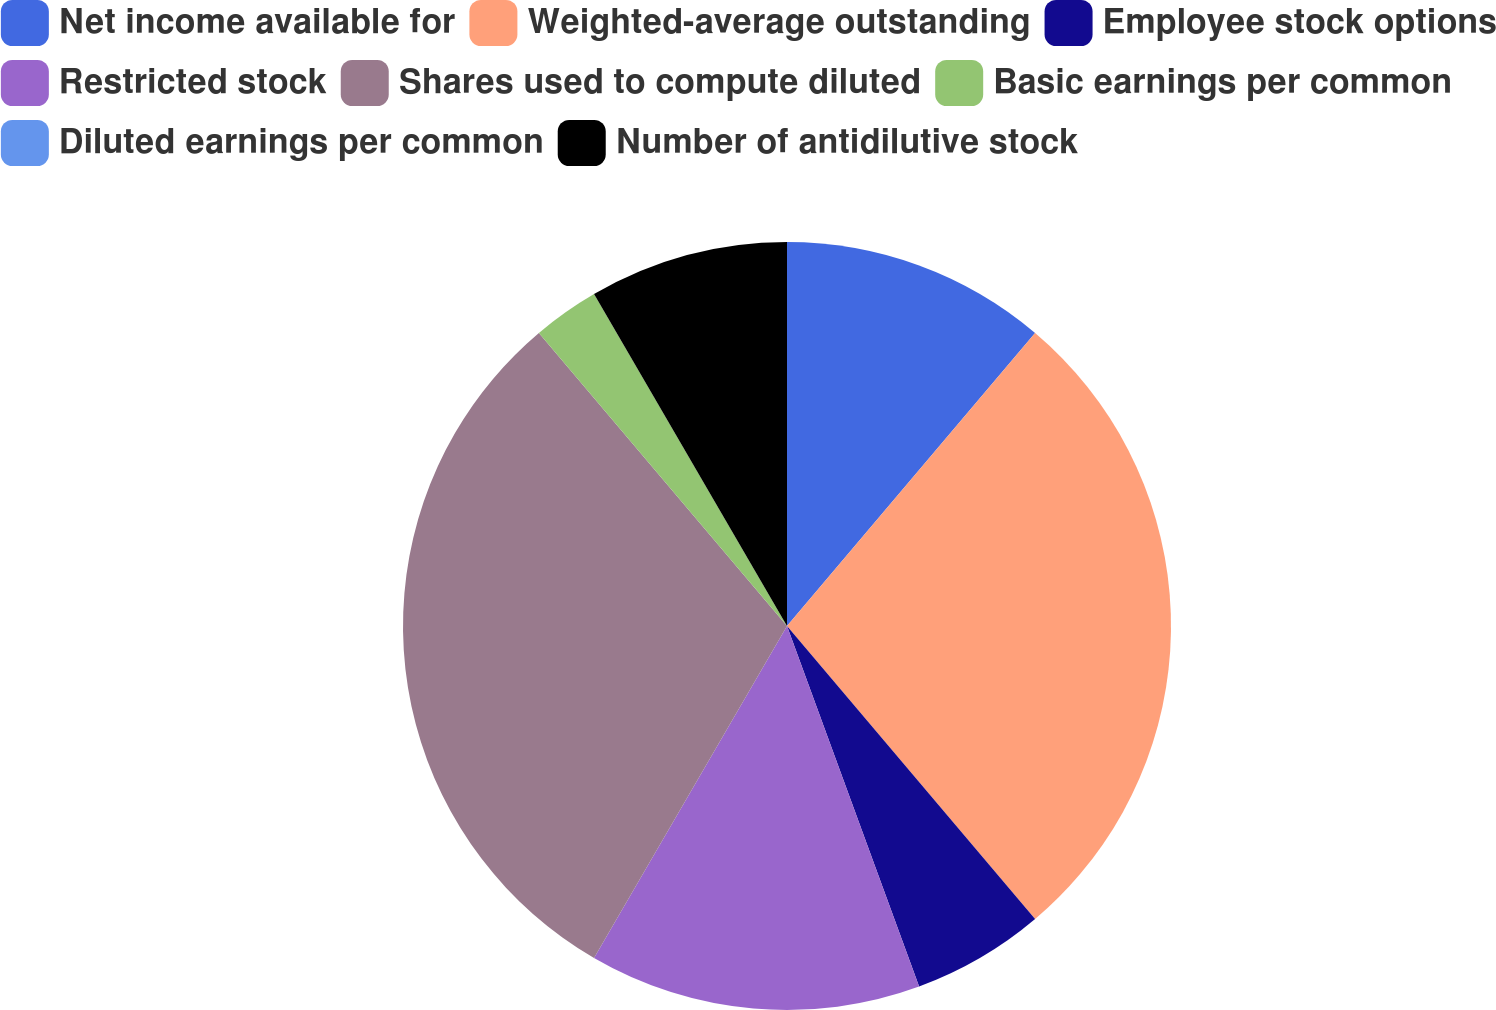Convert chart to OTSL. <chart><loc_0><loc_0><loc_500><loc_500><pie_chart><fcel>Net income available for<fcel>Weighted-average outstanding<fcel>Employee stock options<fcel>Restricted stock<fcel>Shares used to compute diluted<fcel>Basic earnings per common<fcel>Diluted earnings per common<fcel>Number of antidilutive stock<nl><fcel>11.18%<fcel>27.64%<fcel>5.59%<fcel>13.97%<fcel>30.44%<fcel>2.8%<fcel>0.0%<fcel>8.38%<nl></chart> 